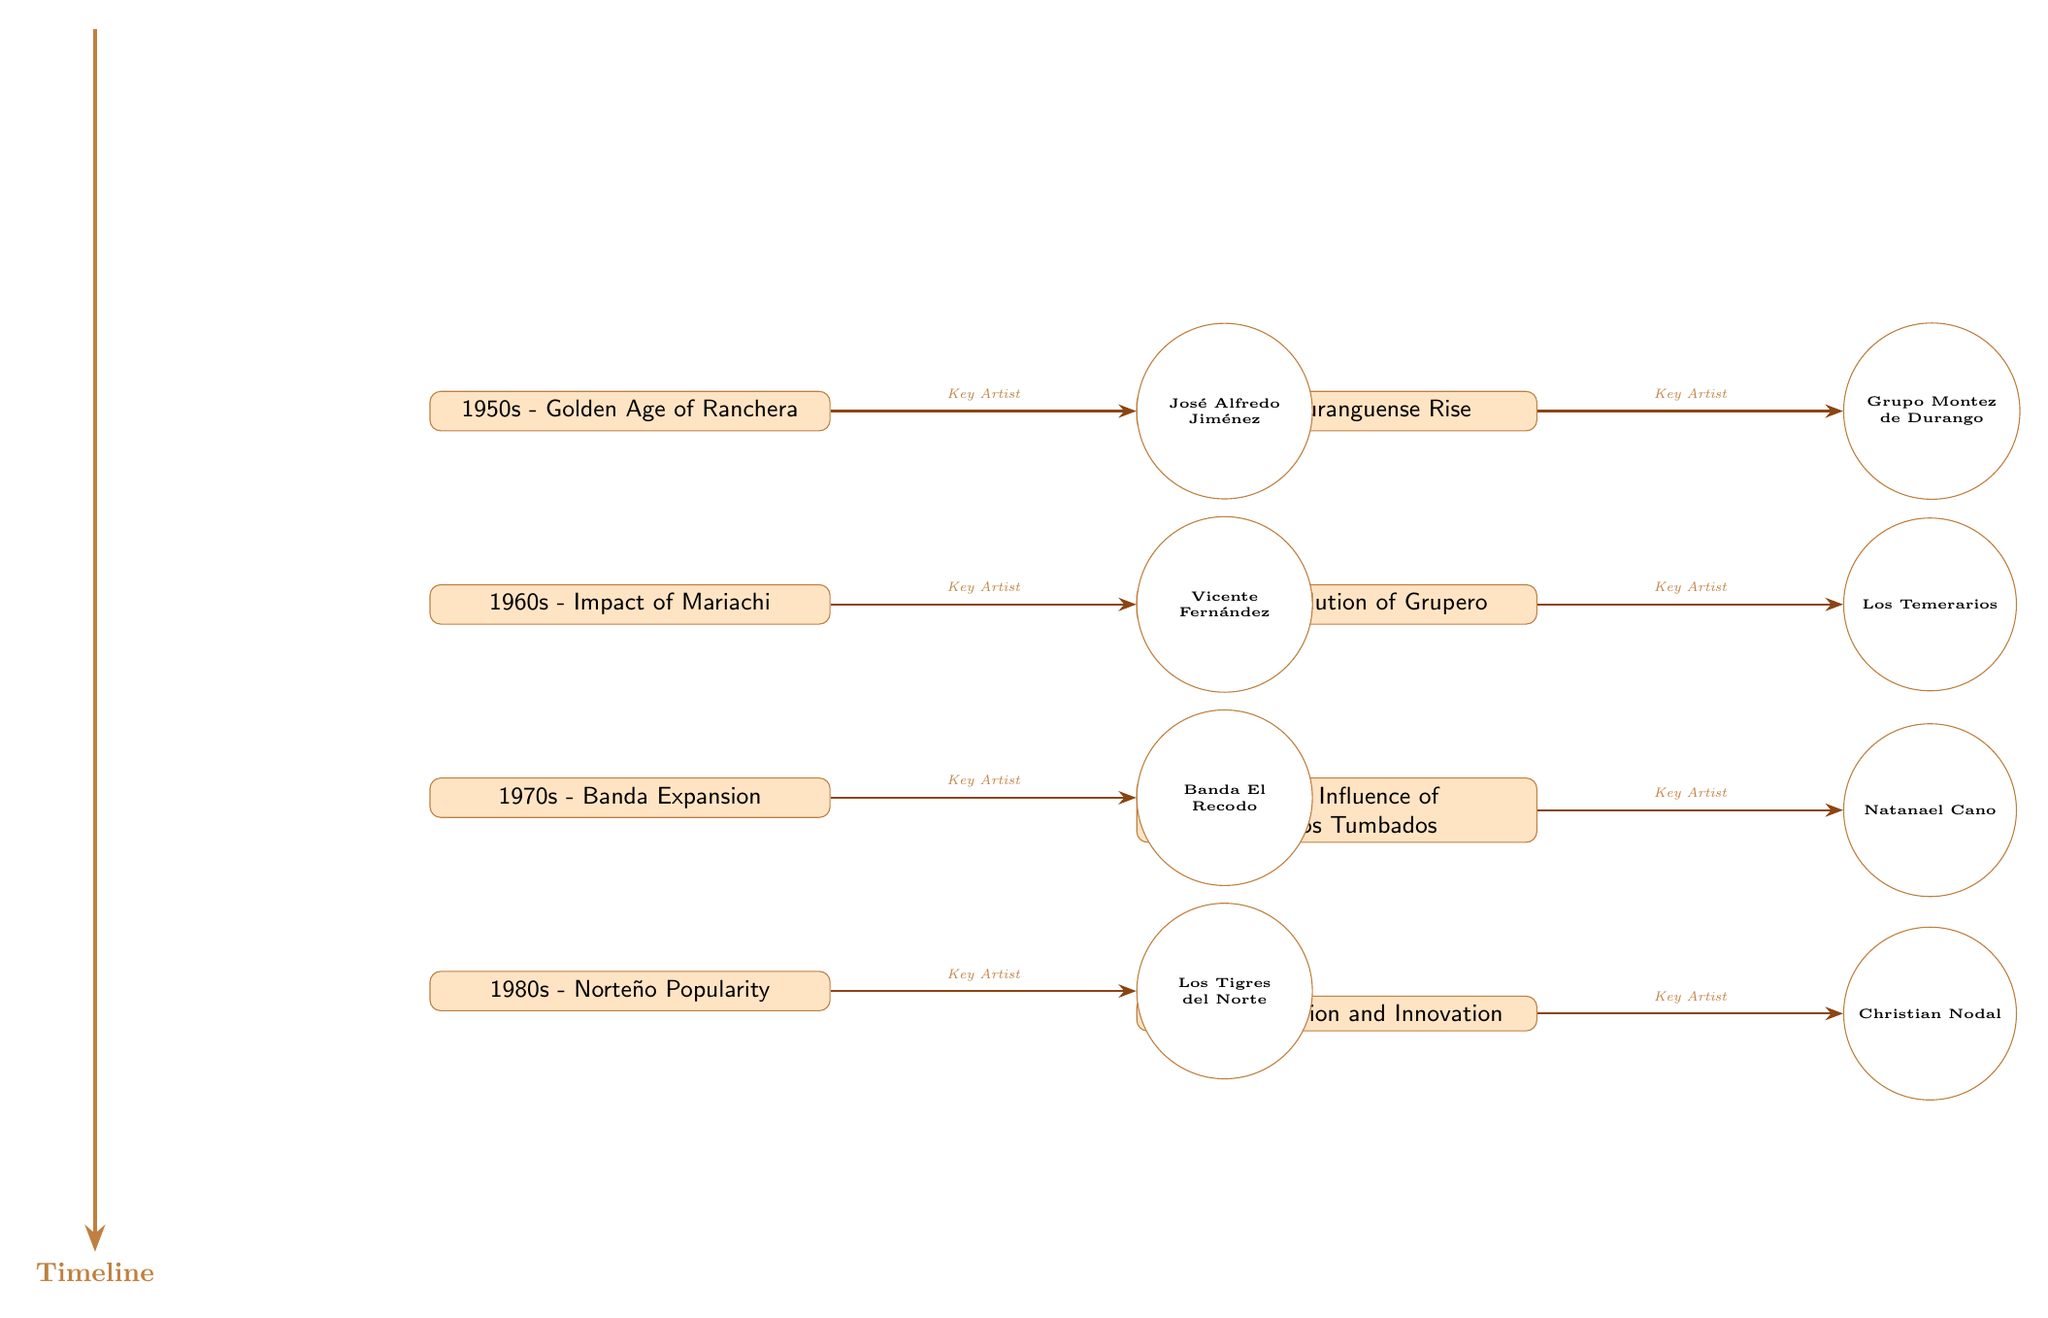What musical genre is associated with the 1950s in this diagram? The node for the 1950s reads "Golden Age of Ranchera," indicating that this is the musical genre associated with that decade.
Answer: Golden Age of Ranchera Who is the key artist linked to the Norteño Popularity of the 1980s? The 1980s node states "Norteño Popularity," and its corresponding key artist to the right is "Los Tigres del Norte."
Answer: Los Tigres del Norte How many distinct music styles are represented in the diagram? There are eight distinct music styles listed in the diagram from the 1950s to the present, displayed as nodes.
Answer: 8 Which decade saw the rise of Duranguense? The diagram indicates that the rise of Duranguense is associated with the 1990s, shown on the right side of the 1950s node.
Answer: 1990s Which artist is associated with the Present era? The node for the Present reads "Fusion and Innovation," and is linked to "Christian Nodal" as the key artist representing this current trend.
Answer: Christian Nodal In which decade do we see the influence of Corridos Tumbados? The influence of Corridos Tumbados is depicted in the 2010s node, which is directly below the 2000s node in the timeline.
Answer: 2010s What is the relationship between the 1970s and the key artist Banda El Recodo? The 1970s node labeled "Banda Expansion" has an arrow pointing towards "Banda El Recodo," indicating that Banda El Recodo is a key artist of that period.
Answer: Key Artist Identify the musical genre evolution from the 2000s to the Present based on the diagram. The 2000s node shows "Evolution of Grupero," which progresses to the Present node indicating "Fusion and Innovation." This suggests a transition from Grupero to more innovative styles in the present.
Answer: Grupero to Fusion and Innovation 